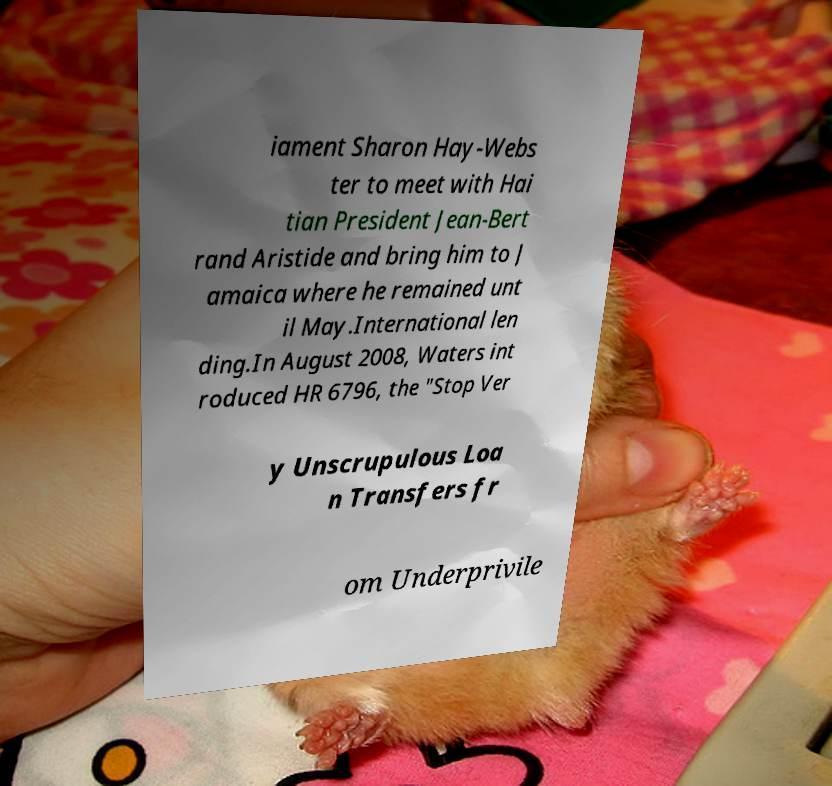Please identify and transcribe the text found in this image. iament Sharon Hay-Webs ter to meet with Hai tian President Jean-Bert rand Aristide and bring him to J amaica where he remained unt il May.International len ding.In August 2008, Waters int roduced HR 6796, the "Stop Ver y Unscrupulous Loa n Transfers fr om Underprivile 